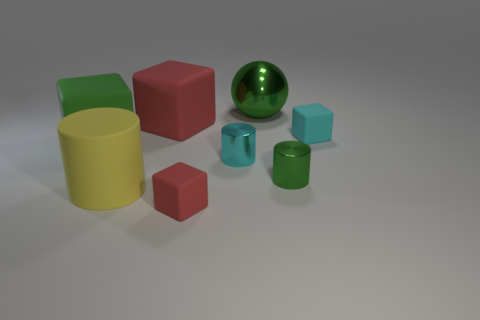How many things are red matte blocks or large metallic objects?
Keep it short and to the point. 3. Is the material of the red object that is in front of the big cylinder the same as the cyan object to the left of the green metal sphere?
Your answer should be compact. No. The other cylinder that is the same material as the green cylinder is what color?
Give a very brief answer. Cyan. How many other green shiny spheres have the same size as the green shiny sphere?
Your response must be concise. 0. How many other things are there of the same color as the metal ball?
Provide a succinct answer. 2. There is a small rubber thing that is to the right of the big green metallic thing; is its shape the same as the small object that is in front of the big rubber cylinder?
Your answer should be compact. Yes. The red thing that is the same size as the cyan metallic cylinder is what shape?
Keep it short and to the point. Cube. Is the number of yellow matte things that are to the left of the large green block the same as the number of large matte things that are left of the tiny red matte block?
Your response must be concise. No. Is there anything else that is the same shape as the large yellow object?
Ensure brevity in your answer.  Yes. Does the cyan object on the right side of the big shiny object have the same material as the small green thing?
Offer a very short reply. No. 